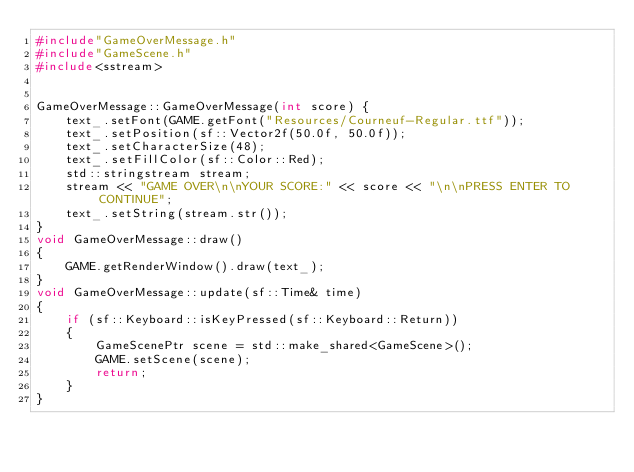Convert code to text. <code><loc_0><loc_0><loc_500><loc_500><_C++_>#include"GameOverMessage.h"
#include"GameScene.h"
#include<sstream>


GameOverMessage::GameOverMessage(int score) {
	text_.setFont(GAME.getFont("Resources/Courneuf-Regular.ttf")); 
	text_.setPosition(sf::Vector2f(50.0f, 50.0f)); 
	text_.setCharacterSize(48); 
	text_.setFillColor(sf::Color::Red); 
	std::stringstream stream; 
	stream << "GAME OVER\n\nYOUR SCORE:" << score << "\n\nPRESS ENTER TO CONTINUE";
	text_.setString(stream.str());
}
void GameOverMessage::draw() 
{ 
	GAME.getRenderWindow().draw(text_); 
}
void GameOverMessage::update(sf::Time& time) 
{ 
	if (sf::Keyboard::isKeyPressed(sf::Keyboard::Return)) 
	{ 
		GameScenePtr scene = std::make_shared<GameScene>(); 
		GAME.setScene(scene); 
		return; 
	} 
}


</code> 